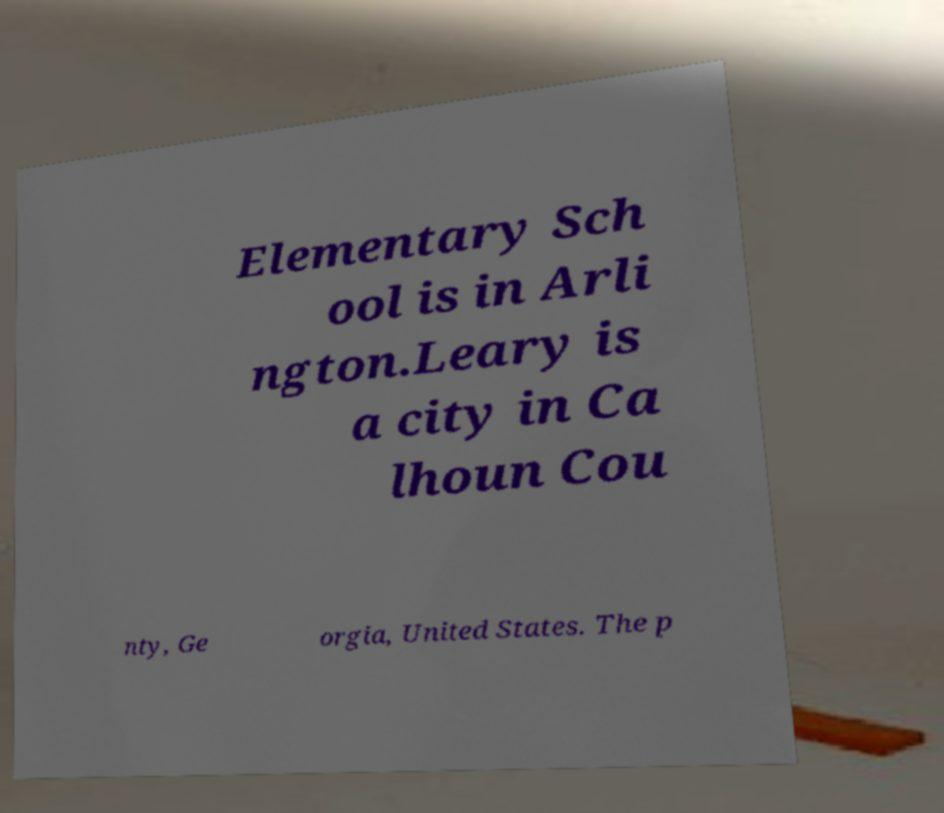Can you accurately transcribe the text from the provided image for me? Elementary Sch ool is in Arli ngton.Leary is a city in Ca lhoun Cou nty, Ge orgia, United States. The p 